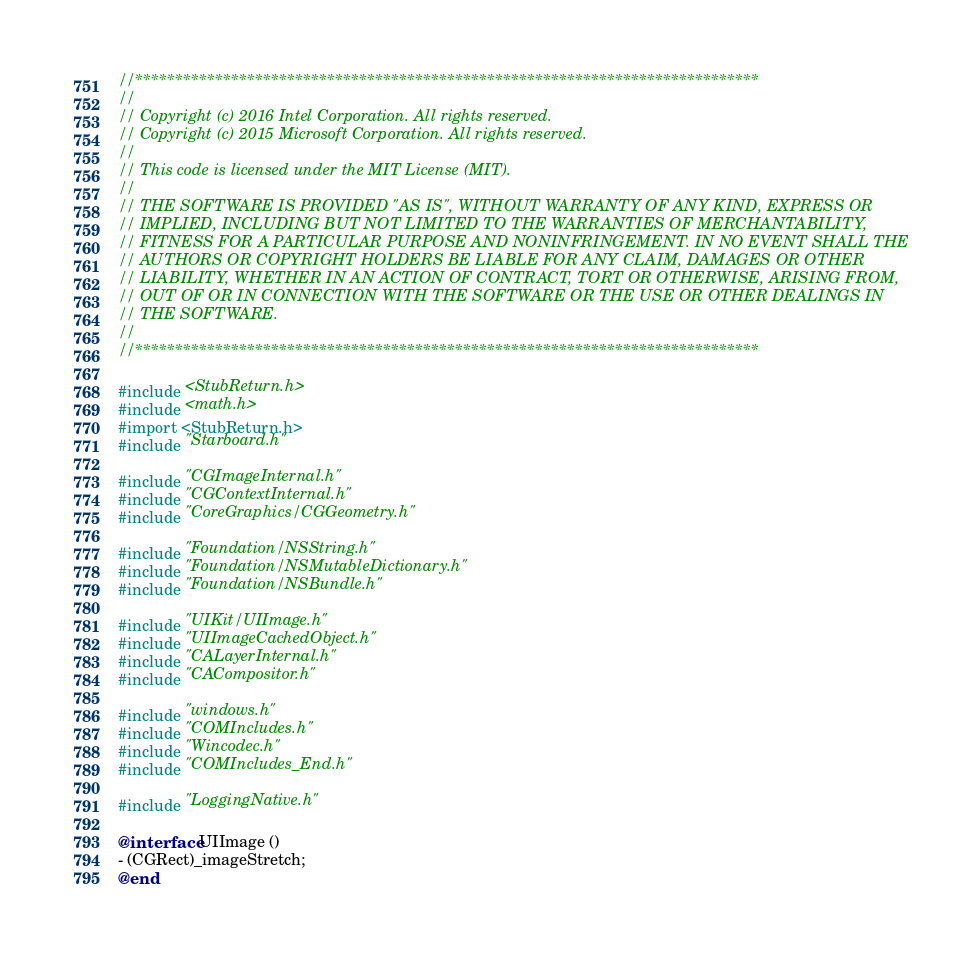Convert code to text. <code><loc_0><loc_0><loc_500><loc_500><_ObjectiveC_>//******************************************************************************
//
// Copyright (c) 2016 Intel Corporation. All rights reserved.
// Copyright (c) 2015 Microsoft Corporation. All rights reserved.
//
// This code is licensed under the MIT License (MIT).
//
// THE SOFTWARE IS PROVIDED "AS IS", WITHOUT WARRANTY OF ANY KIND, EXPRESS OR
// IMPLIED, INCLUDING BUT NOT LIMITED TO THE WARRANTIES OF MERCHANTABILITY,
// FITNESS FOR A PARTICULAR PURPOSE AND NONINFRINGEMENT. IN NO EVENT SHALL THE
// AUTHORS OR COPYRIGHT HOLDERS BE LIABLE FOR ANY CLAIM, DAMAGES OR OTHER
// LIABILITY, WHETHER IN AN ACTION OF CONTRACT, TORT OR OTHERWISE, ARISING FROM,
// OUT OF OR IN CONNECTION WITH THE SOFTWARE OR THE USE OR OTHER DEALINGS IN
// THE SOFTWARE.
//
//******************************************************************************

#include <StubReturn.h>
#include <math.h>
#import <StubReturn.h>
#include "Starboard.h"

#include "CGImageInternal.h"
#include "CGContextInternal.h"
#include "CoreGraphics/CGGeometry.h"

#include "Foundation/NSString.h"
#include "Foundation/NSMutableDictionary.h"
#include "Foundation/NSBundle.h"

#include "UIKit/UIImage.h"
#include "UIImageCachedObject.h"
#include "CALayerInternal.h"
#include "CACompositor.h"

#include "windows.h"
#include "COMIncludes.h"
#include "Wincodec.h"
#include "COMIncludes_End.h"

#include "LoggingNative.h"

@interface UIImage ()
- (CGRect)_imageStretch;
@end
</code> 